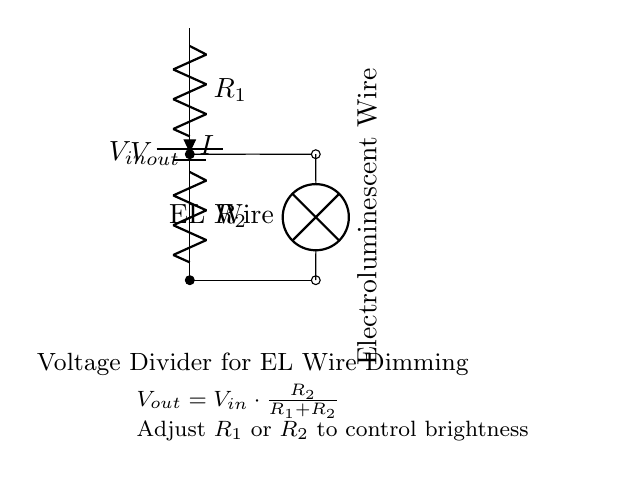What is the input voltage in this circuit? The circuit shows a battery labeled V_in, which represents the input voltage. Since there is no numerical value specified beside it, we conclude that it's a general representation.
Answer: V_in What components are used in the circuit? The circuit includes a battery, two resistors (R_1 and R_2), and an electroluminescent wire (EL Wire). These components are clearly labeled in the diagram.
Answer: Battery, R_1, R_2, EL Wire How is the output voltage related to the input voltage? The output voltage, V_out, is calculated using the formula provided in the diagram: V_out = V_in * (R_2 / (R_1 + R_2)). This indicates that the output voltage is a fraction of the input voltage, depending on the values of R_1 and R_2.
Answer: V_out = V_in * (R_2 / (R_1 + R_2)) What happens to brightness when R_1 is increased? Increasing R_1 will decrease V_out due to the voltage divider principle, meaning less voltage will be supplied to the electroluminescent wire. As a result, the brightness of the EL wire will dim.
Answer: Dims What is the purpose of this voltage divider circuit? The primary purpose is to adjust the output voltage to power and control the brightness of the electroluminescent wire used in avant-garde gown designs, allowing for creative effects in the fashion display.
Answer: Power and dim EL Wire 